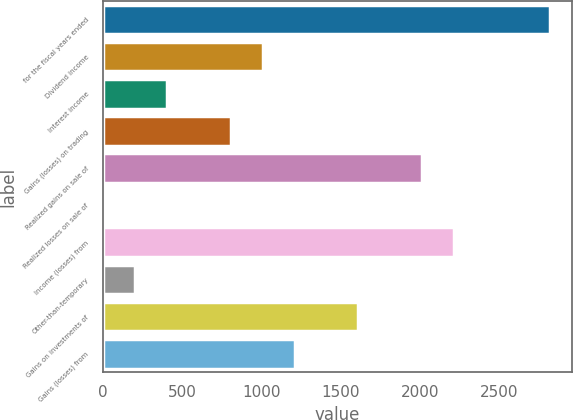Convert chart. <chart><loc_0><loc_0><loc_500><loc_500><bar_chart><fcel>for the fiscal years ended<fcel>Dividend income<fcel>Interest income<fcel>Gains (losses) on trading<fcel>Realized gains on sale of<fcel>Realized losses on sale of<fcel>Income (losses) from<fcel>Other-than-temporary<fcel>Gains on investments of<fcel>Gains (losses) from<nl><fcel>2817.84<fcel>1006.95<fcel>403.32<fcel>805.74<fcel>2013<fcel>0.9<fcel>2214.21<fcel>202.11<fcel>1610.58<fcel>1208.16<nl></chart> 